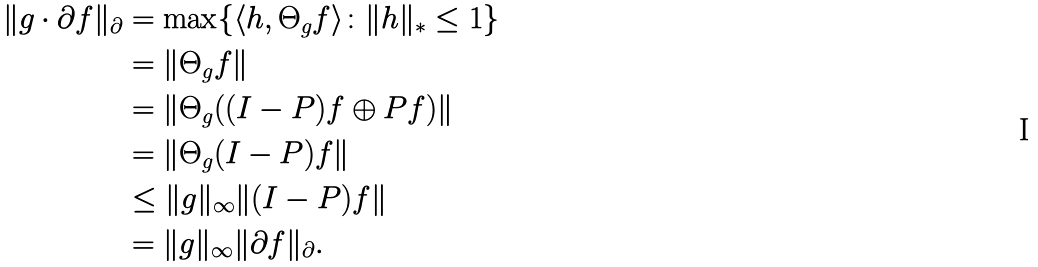Convert formula to latex. <formula><loc_0><loc_0><loc_500><loc_500>\| g \cdot \partial f \| _ { \partial } & = \max \{ \langle h , \Theta _ { g } f \rangle \colon \| h \| _ { * } \leq 1 \} \\ & = \| \Theta _ { g } f \| \\ & = \| \Theta _ { g } ( ( I - P ) f \oplus P f ) \| \\ & = \| \Theta _ { g } ( I - P ) f \| \\ & \leq \| g \| _ { \infty } \| ( I - P ) f \| \\ & = \| g \| _ { \infty } \| \partial f \| _ { \partial } .</formula> 